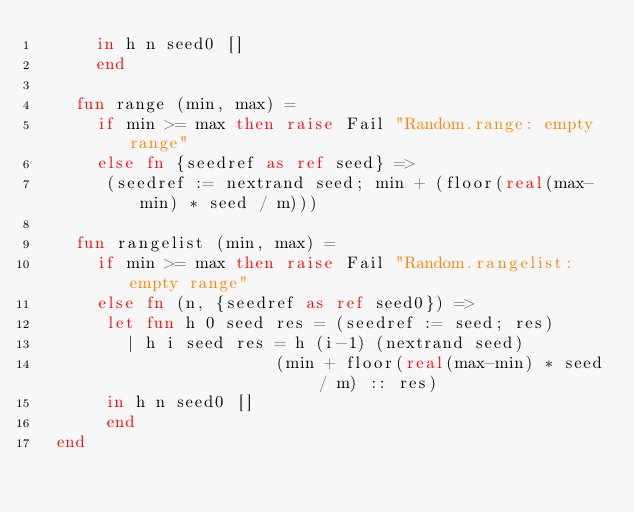<code> <loc_0><loc_0><loc_500><loc_500><_SML_>      in h n seed0 [] 
      end

    fun range (min, max) = 
      if min >= max then raise Fail "Random.range: empty range" 
      else fn {seedref as ref seed} =>
	   (seedref := nextrand seed; min + (floor(real(max-min) * seed / m)))

    fun rangelist (min, max) =
      if min >= max then raise Fail "Random.rangelist: empty range" 
      else fn (n, {seedref as ref seed0}) => 
	   let fun h 0 seed res = (seedref := seed; res)
		 | h i seed res = h (i-1) (nextrand seed) 
	                    (min + floor(real(max-min) * seed / m) :: res)
	   in h n seed0 [] 
	   end
  end
</code> 